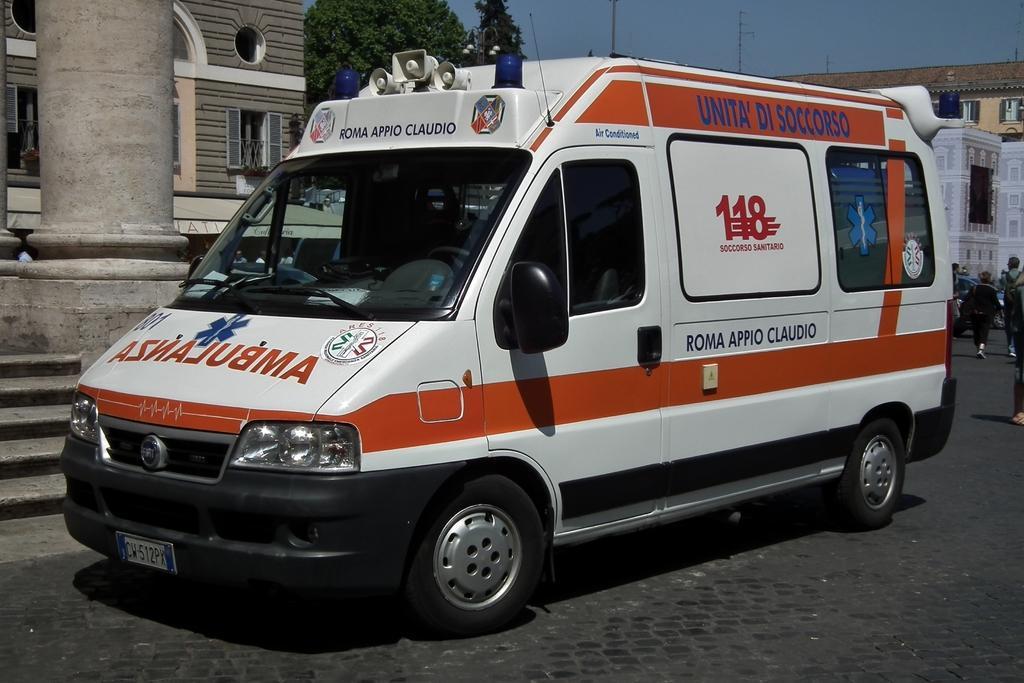Describe this image in one or two sentences. In this image we can see a vehicle parked on the road. In the background, we can see a group of people standing on the road, a group of trees, buildings and sky. 